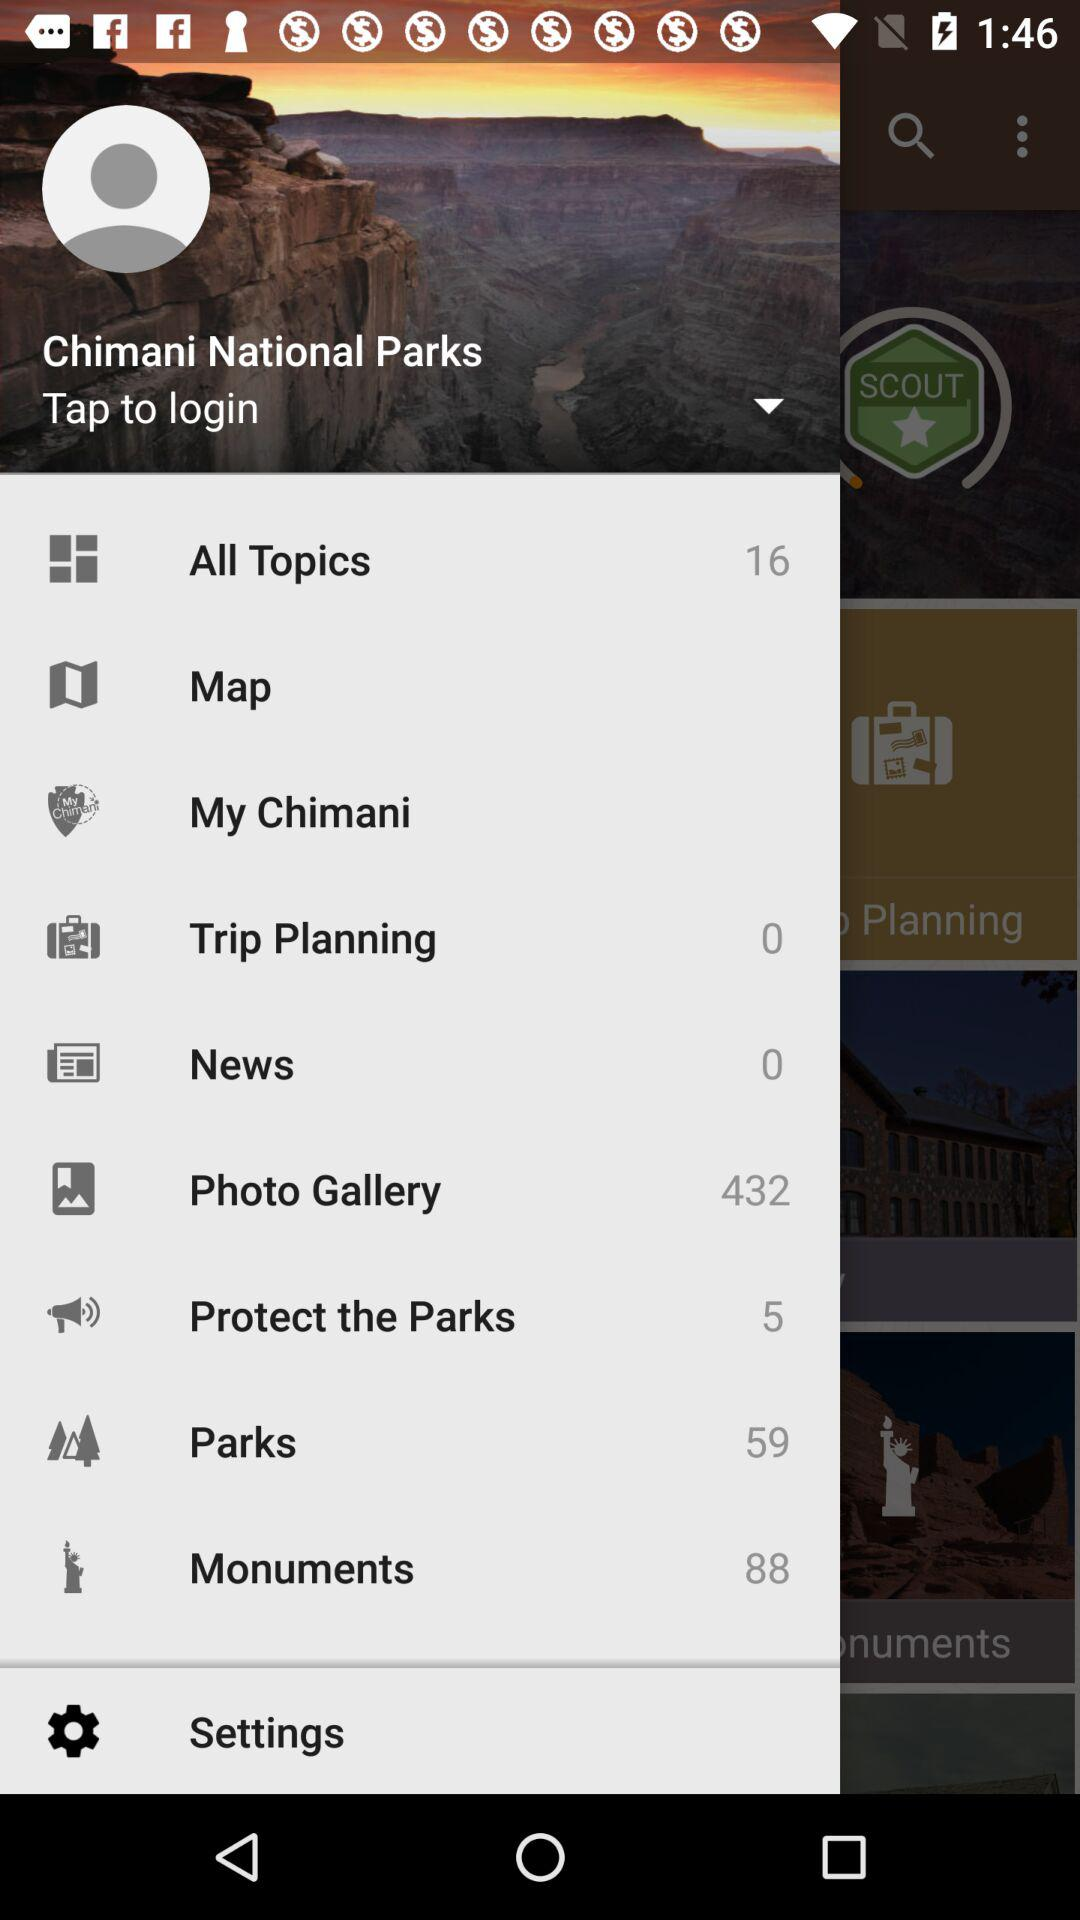What is the number of "Monuments"? The number of monuments is 88. 